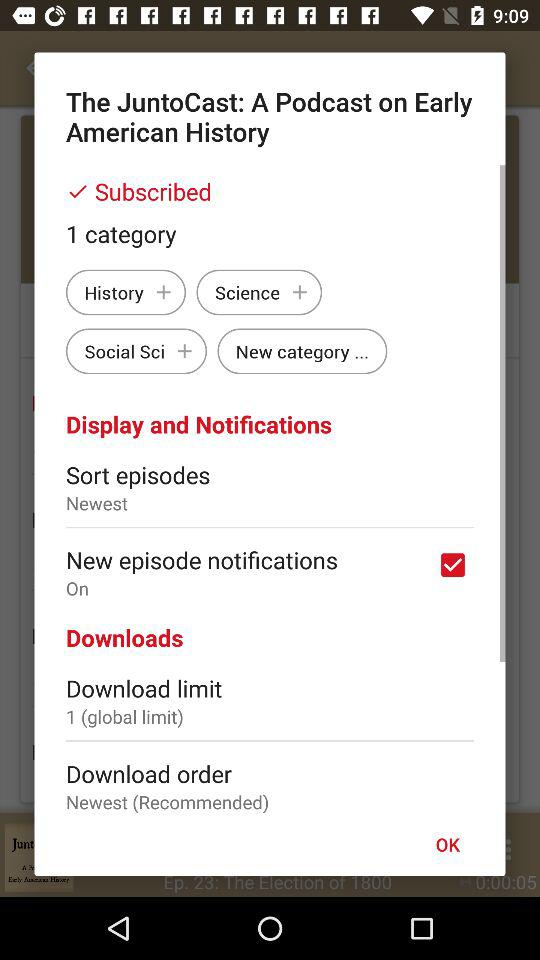What option is selected in "Sort episodes"? The option selected is "Newest". 